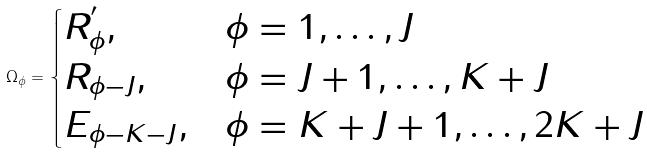Convert formula to latex. <formula><loc_0><loc_0><loc_500><loc_500>{ \Omega _ { \phi } } = \begin{cases} R ^ { ^ { \prime } } _ { \phi } , & \phi = 1 , \dots , J \\ R _ { \phi - J } , & \phi = J + 1 , \dots , K + J \\ E _ { \phi - K - J } , & \phi = K + J + 1 , \dots , 2 K + J \\ \end{cases}</formula> 